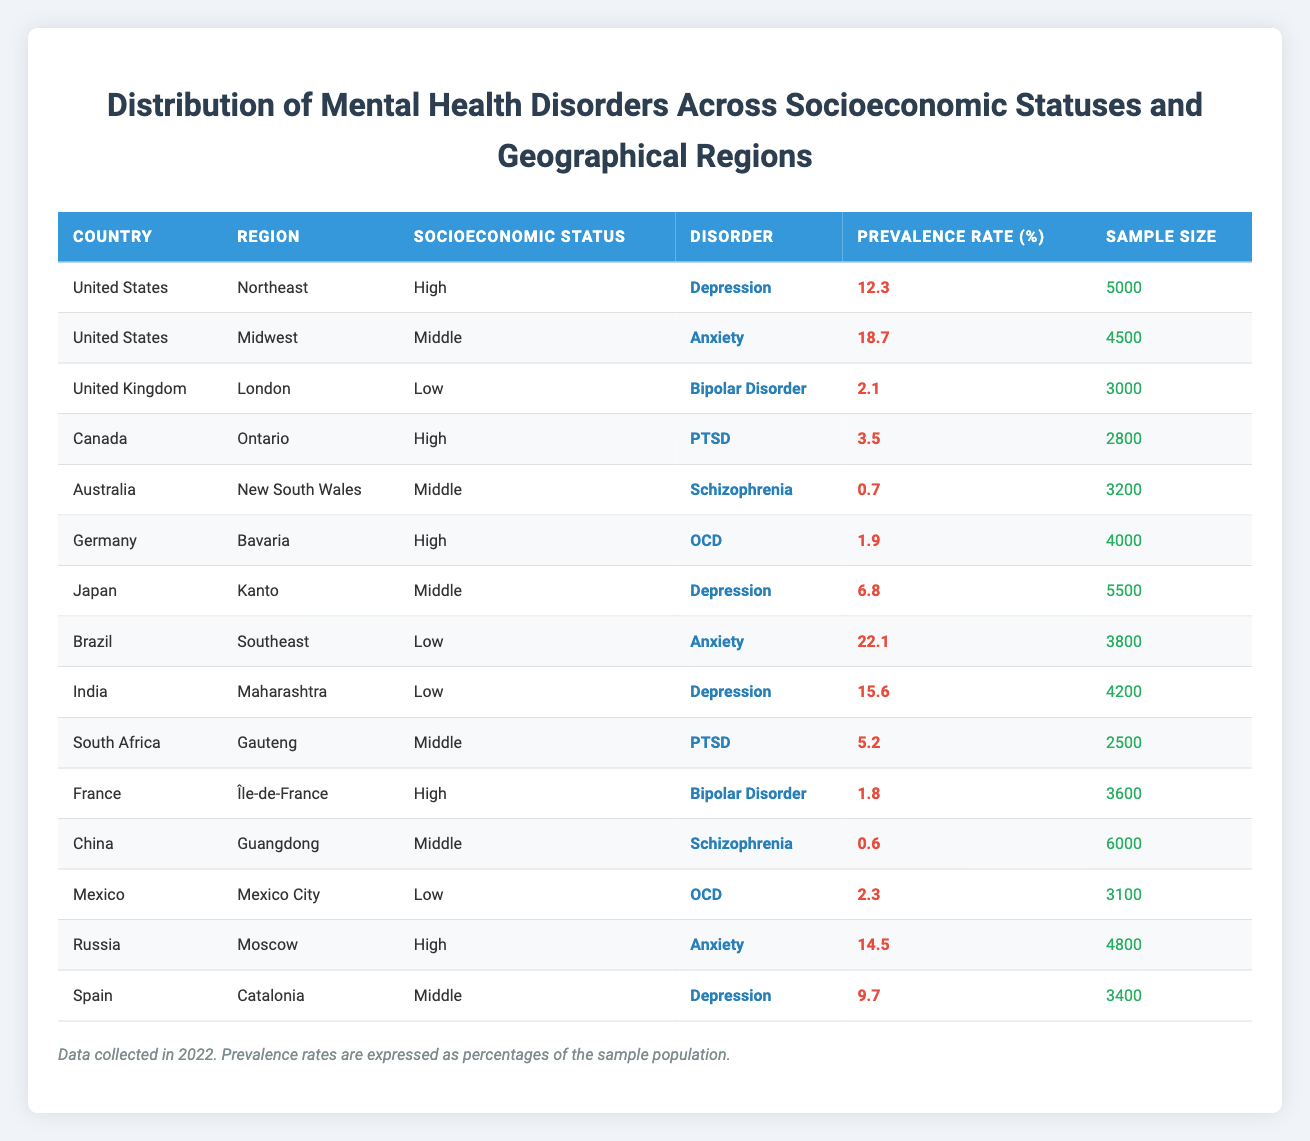What is the prevalence rate of Anxiety in the United States Midwest? According to the table, for the United States in the Midwest region, the disorder is Anxiety, and the prevalence rate is listed as 18.7%.
Answer: 18.7 Which disorder has the highest prevalence rate among low socioeconomic status individuals? From the table, the prevalence rates for low socioeconomic status individuals are 2.1% (Bipolar Disorder), 22.1% (Anxiety in Brazil), and 15.6% (Depression in India). The highest is 22.1%, which corresponds to Anxiety in Brazil.
Answer: 22.1 Is there any country where PTSD is listed under high socioeconomic status? In the table, PTSD appears under Canada (High socioeconomic status) with a prevalence rate of 3.5%. Therefore, the statement is true.
Answer: Yes What is the average prevalence rate of Schizophrenia across Middle socioeconomic status regions? Schizophrenia appears in two regions with Middle socioeconomic status: 0.7% in Australia (New South Wales) and 0.6% in China (Guangdong). To find the average, add these two rates (0.7 + 0.6 = 1.3) and then divide by the number of data points, which is 2. The average prevalence rate is 1.3 / 2 = 0.65%.
Answer: 0.65 Which country and region have the lowest sample size for a disorder? Reviewing the sample sizes in the table, the lowest is 2500 under the disorder PTSD in South Africa (Gauteng region).
Answer: South Africa, Gauteng What is the difference in prevalence rates of Depression between the United States and Japan? The prevalence rate for Depression in the United States (Northeast) is 12.3%, while in Japan (Kanto), it is 6.8%. To find the difference, subtract Japan's rate from the United States rate: 12.3 - 6.8 = 5.5%.
Answer: 5.5 Are there any instances of Bipolar Disorder listed under a Middle socioeconomic status? The table shows Bipolar Disorder listed under Low (United Kingdom) and High (France) socioeconomic statuses but does not list it under any Middle socioeconomic status. Therefore, the statement is false.
Answer: No What is the total prevalence rate for anxiety disorders across all regions listed? In the table, the following prevalence rates for Anxiety are noted: 18.7% (Midwest, United States), 22.1% (Southeast, Brazil), and 14.5% (Moscow, Russia). To find the total, sum these rates: 18.7 + 22.1 + 14.5 = 55.3%.
Answer: 55.3 